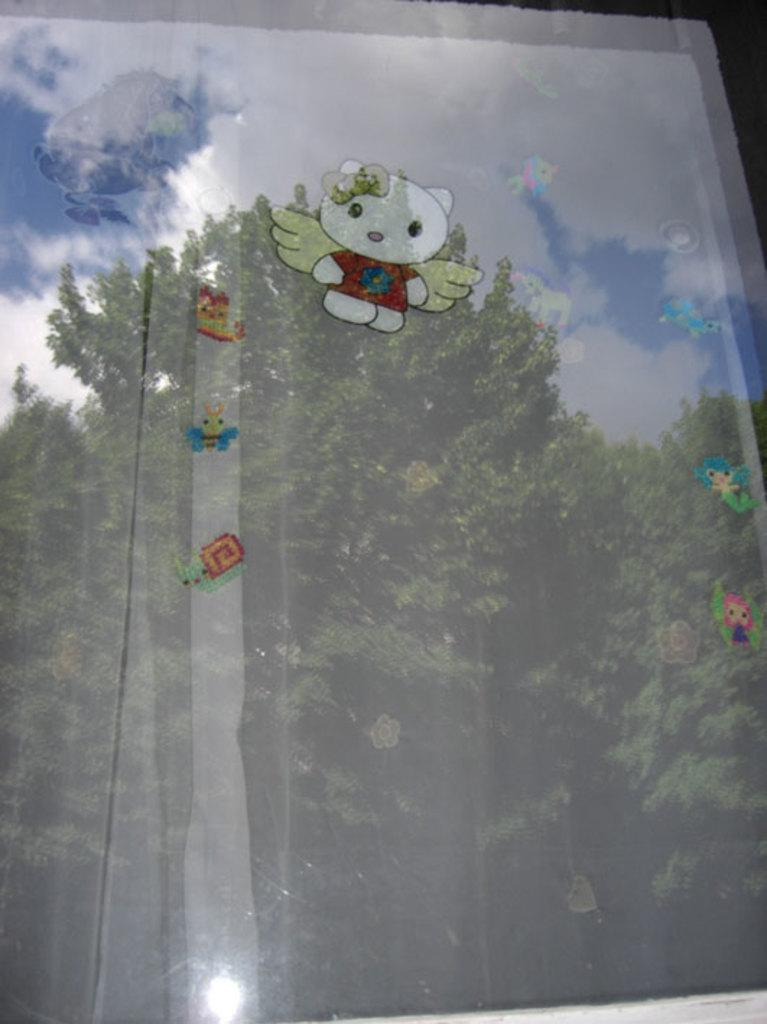What is on the glass in the foreground of the image? There are stickers on the glass in the foreground of the image. What can be seen in the background of the image? There are trees and the sky visible in the background of the image. What is the condition of the sky in the image? The sky is visible in the background of the image, and there are clouds present. What type of manager is overseeing the trees in the background of the image? There is no manager present in the image, and the trees are not being overseen by anyone. Is there a spy hiding behind the clouds in the sky? There is no spy present in the image, and the clouds are not hiding any person or object. 